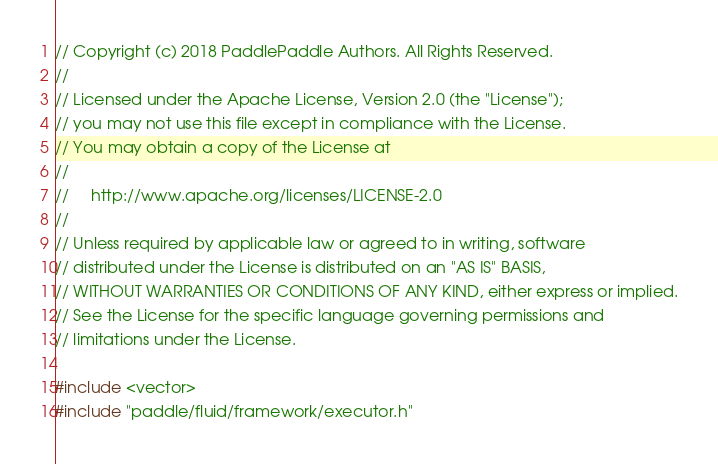<code> <loc_0><loc_0><loc_500><loc_500><_C++_>// Copyright (c) 2018 PaddlePaddle Authors. All Rights Reserved.
//
// Licensed under the Apache License, Version 2.0 (the "License");
// you may not use this file except in compliance with the License.
// You may obtain a copy of the License at
//
//     http://www.apache.org/licenses/LICENSE-2.0
//
// Unless required by applicable law or agreed to in writing, software
// distributed under the License is distributed on an "AS IS" BASIS,
// WITHOUT WARRANTIES OR CONDITIONS OF ANY KIND, either express or implied.
// See the License for the specific language governing permissions and
// limitations under the License.

#include <vector>
#include "paddle/fluid/framework/executor.h"</code> 